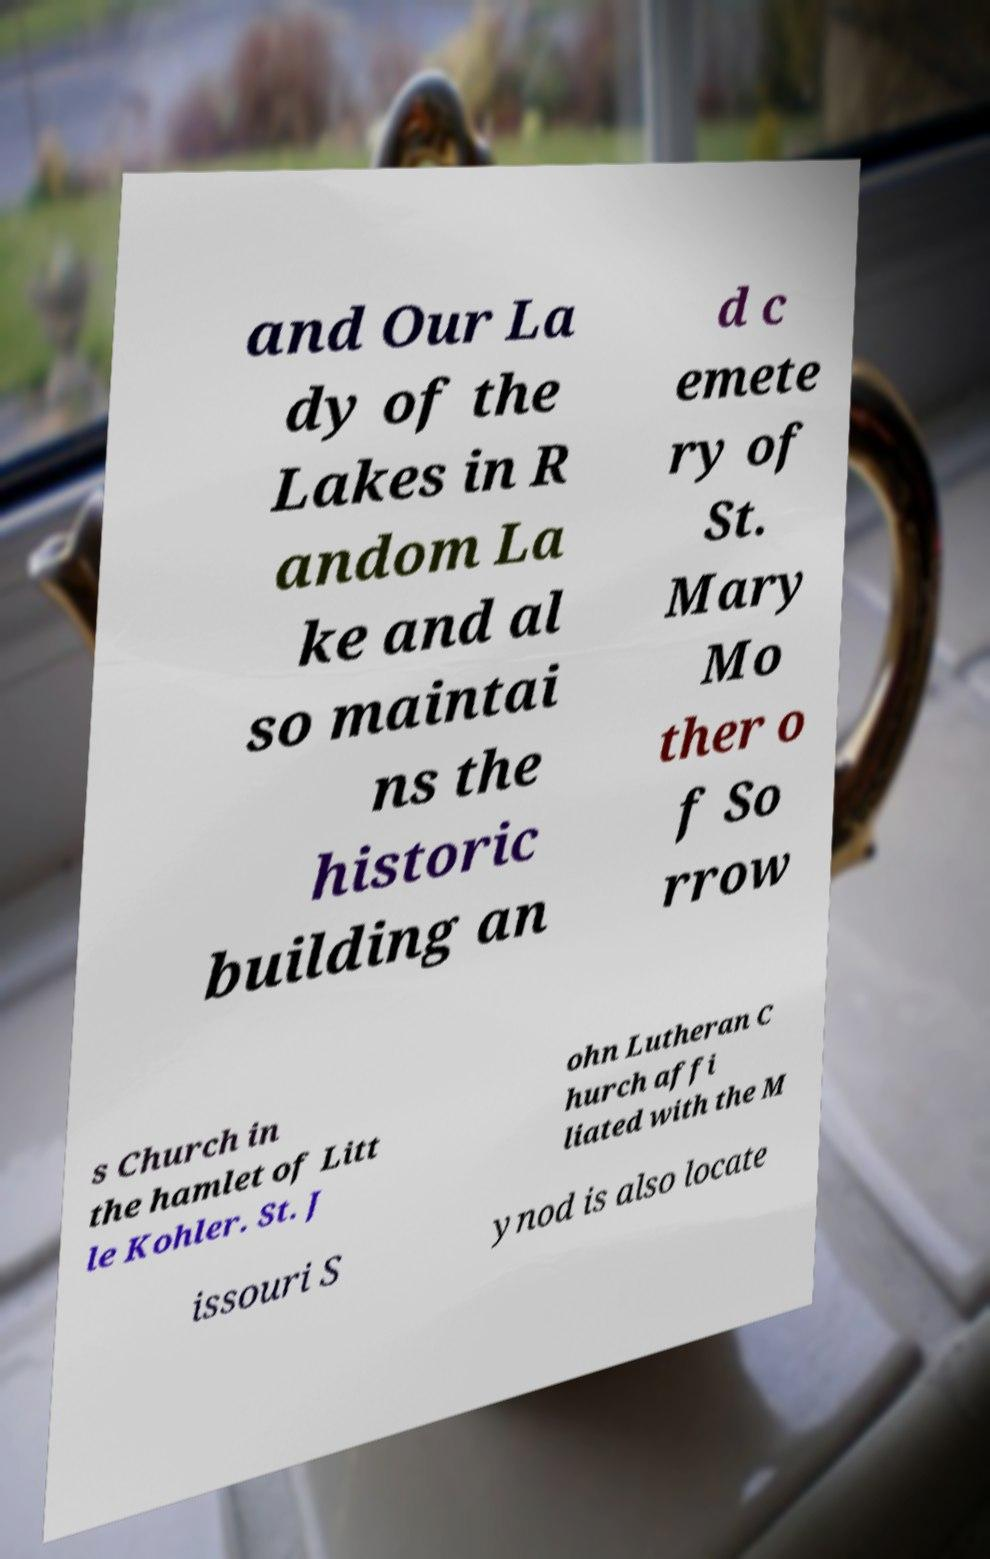Can you read and provide the text displayed in the image?This photo seems to have some interesting text. Can you extract and type it out for me? and Our La dy of the Lakes in R andom La ke and al so maintai ns the historic building an d c emete ry of St. Mary Mo ther o f So rrow s Church in the hamlet of Litt le Kohler. St. J ohn Lutheran C hurch affi liated with the M issouri S ynod is also locate 